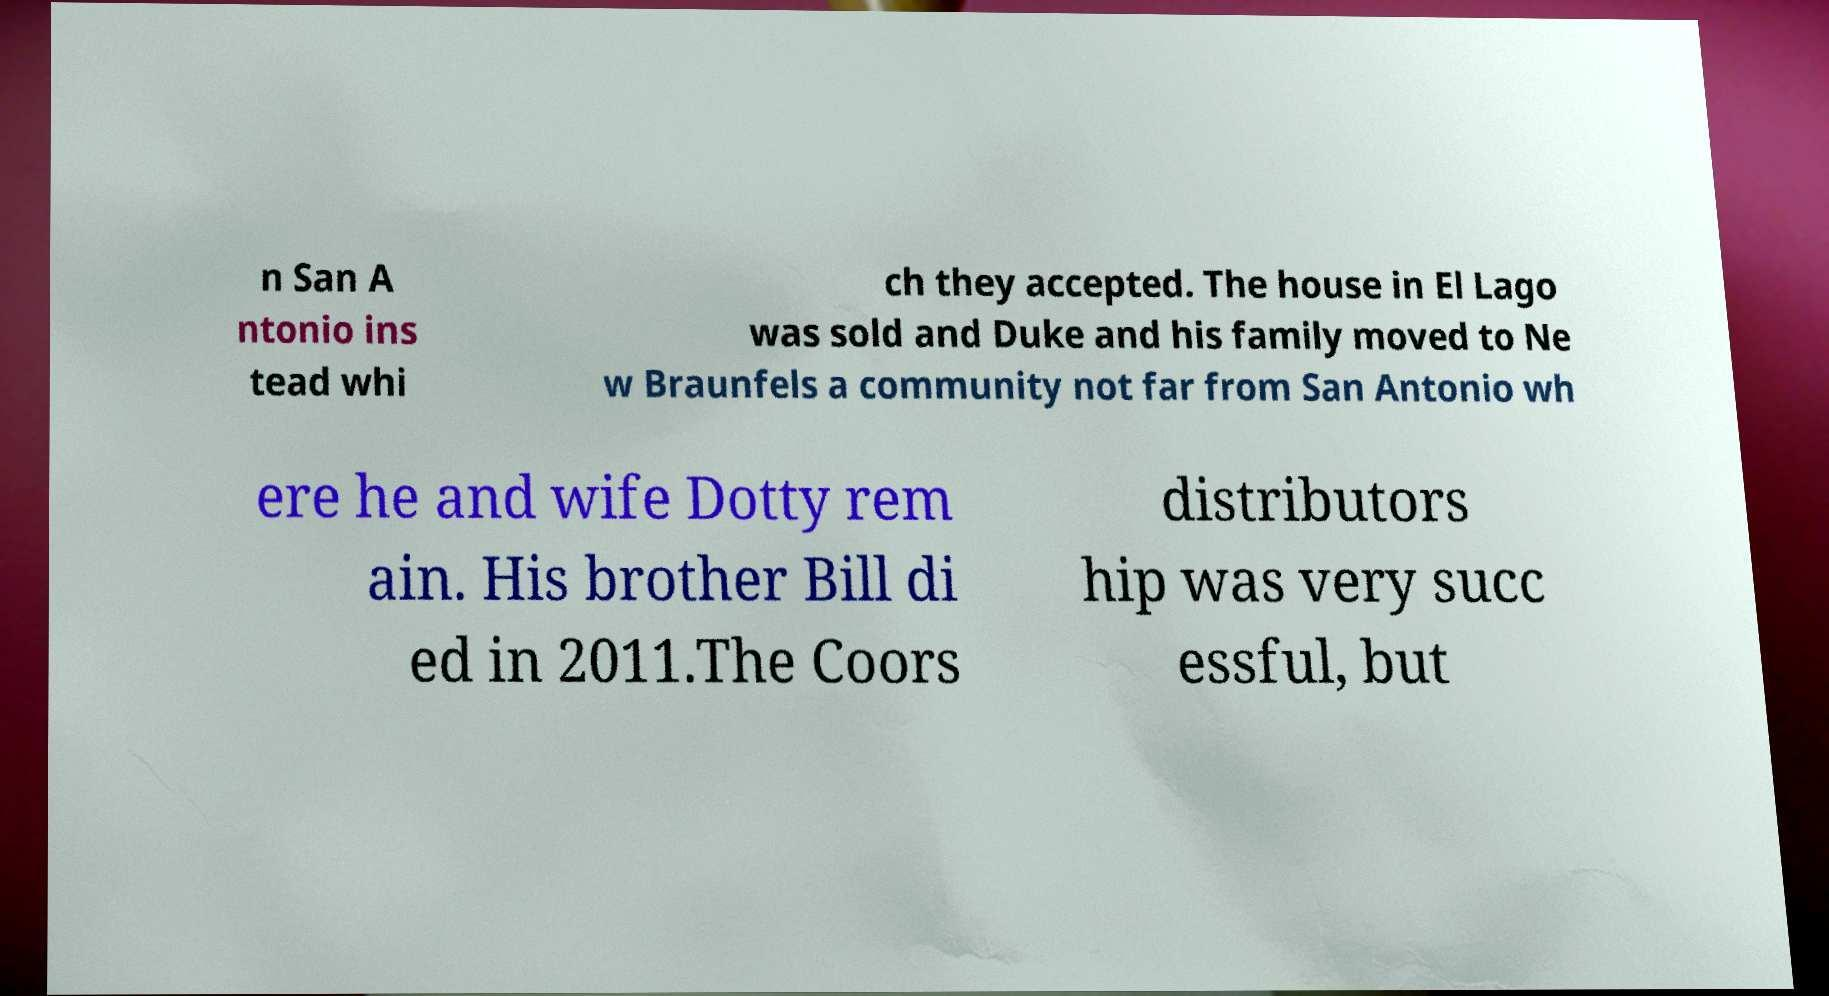Can you accurately transcribe the text from the provided image for me? n San A ntonio ins tead whi ch they accepted. The house in El Lago was sold and Duke and his family moved to Ne w Braunfels a community not far from San Antonio wh ere he and wife Dotty rem ain. His brother Bill di ed in 2011.The Coors distributors hip was very succ essful, but 